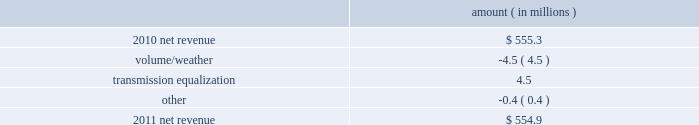Entergy mississippi , inc .
Management 2019s financial discussion and analysis plan to spin off the utility 2019s transmission business see the 201cplan to spin off the utility 2019s transmission business 201d section of entergy corporation and subsidiaries management 2019s financial discussion and analysis for a discussion of this matter , including the planned retirement of debt and preferred securities .
Results of operations net income 2011 compared to 2010 net income increased $ 23.4 million primarily due to a lower effective income tax rate .
2010 compared to 2009 net income increased $ 6.0 million primarily due to higher net revenue and higher other income , partially offset by higher taxes other than income taxes , higher depreciation and amortization expenses , and higher interest expense .
Net revenue 2011 compared to 2010 net revenue consists of operating revenues net of : 1 ) fuel , fuel-related expenses , and gas purchased for resale , 2 ) purchased power expenses , and 3 ) other regulatory charges ( credits ) .
Following is an analysis of the change in net revenue comparing 2011 to 2010 .
Amount ( in millions ) .
The volume/weather variance is primarily due to a decrease of 97 gwh in weather-adjusted usage in the residential and commercial sectors and a decrease in sales volume in the unbilled sales period .
The transmission equalization variance is primarily due to the addition in 2011 of transmission investments that are subject to equalization .
Gross operating revenues and fuel and purchased power expenses gross operating revenues increased primarily due to an increase of $ 57.5 million in gross wholesale revenues due to an increase in sales to affiliated customers , partially offset by a decrease of $ 26.9 million in power management rider revenue .
Fuel and purchased power expenses increased primarily due to an increase in deferred fuel expense as a result of higher fuel revenues due to higher fuel rates , partially offset by a decrease in the average market prices of natural gas and purchased power. .
What is the net change in net revenues from 2010 to 2011? 
Computations: (554.9 - 555.3)
Answer: -0.4. 